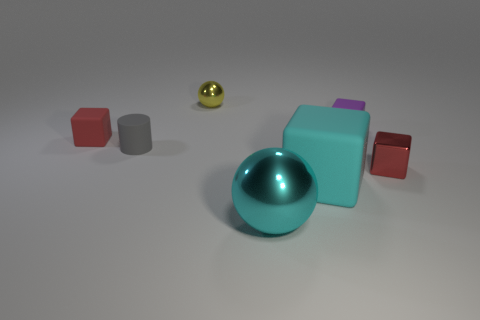There is a tiny thing that is on the right side of the gray object and to the left of the big shiny ball; what is it made of?
Give a very brief answer. Metal. Is there a tiny gray matte cylinder right of the red thing that is in front of the tiny cube that is to the left of the big rubber block?
Ensure brevity in your answer.  No. The sphere that is the same color as the large matte object is what size?
Give a very brief answer. Large. Are there any blocks to the right of the small yellow object?
Ensure brevity in your answer.  Yes. How many other things are there of the same shape as the big shiny object?
Keep it short and to the point. 1. What is the color of the other shiny block that is the same size as the purple block?
Provide a short and direct response. Red. Are there fewer large cyan rubber things that are behind the small cylinder than metal blocks in front of the cyan matte object?
Offer a terse response. No. What number of tiny red rubber cubes are behind the shiny object that is in front of the small red object that is on the right side of the tiny ball?
Your response must be concise. 1. The purple object that is the same shape as the cyan matte thing is what size?
Your response must be concise. Small. Is there any other thing that is the same size as the cyan matte block?
Keep it short and to the point. Yes. 